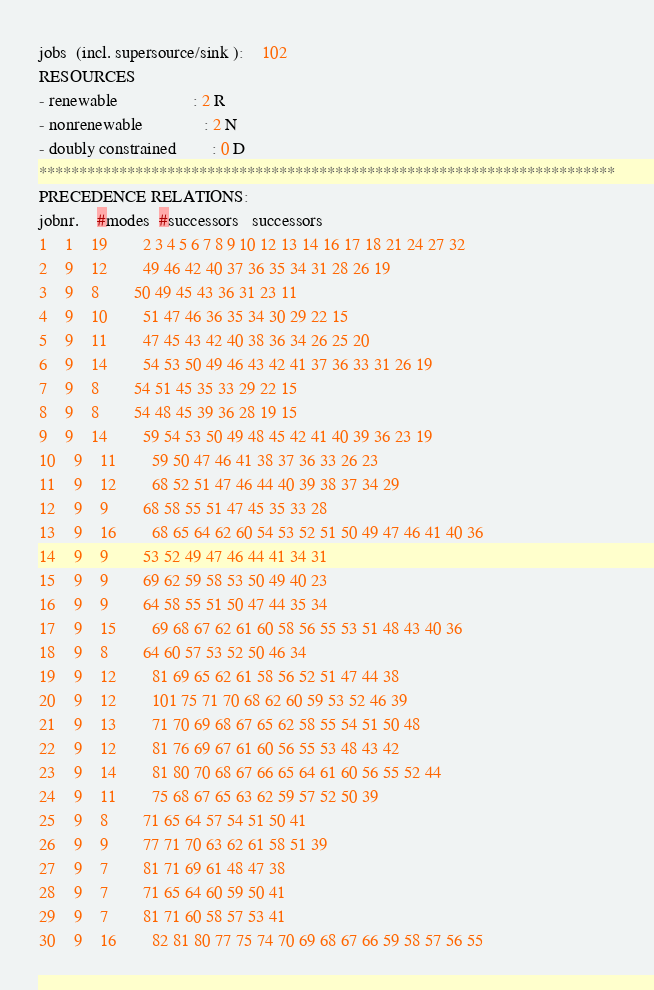Convert code to text. <code><loc_0><loc_0><loc_500><loc_500><_ObjectiveC_>jobs  (incl. supersource/sink ):	102
RESOURCES
- renewable                 : 2 R
- nonrenewable              : 2 N
- doubly constrained        : 0 D
************************************************************************
PRECEDENCE RELATIONS:
jobnr.    #modes  #successors   successors
1	1	19		2 3 4 5 6 7 8 9 10 12 13 14 16 17 18 21 24 27 32 
2	9	12		49 46 42 40 37 36 35 34 31 28 26 19 
3	9	8		50 49 45 43 36 31 23 11 
4	9	10		51 47 46 36 35 34 30 29 22 15 
5	9	11		47 45 43 42 40 38 36 34 26 25 20 
6	9	14		54 53 50 49 46 43 42 41 37 36 33 31 26 19 
7	9	8		54 51 45 35 33 29 22 15 
8	9	8		54 48 45 39 36 28 19 15 
9	9	14		59 54 53 50 49 48 45 42 41 40 39 36 23 19 
10	9	11		59 50 47 46 41 38 37 36 33 26 23 
11	9	12		68 52 51 47 46 44 40 39 38 37 34 29 
12	9	9		68 58 55 51 47 45 35 33 28 
13	9	16		68 65 64 62 60 54 53 52 51 50 49 47 46 41 40 36 
14	9	9		53 52 49 47 46 44 41 34 31 
15	9	9		69 62 59 58 53 50 49 40 23 
16	9	9		64 58 55 51 50 47 44 35 34 
17	9	15		69 68 67 62 61 60 58 56 55 53 51 48 43 40 36 
18	9	8		64 60 57 53 52 50 46 34 
19	9	12		81 69 65 62 61 58 56 52 51 47 44 38 
20	9	12		101 75 71 70 68 62 60 59 53 52 46 39 
21	9	13		71 70 69 68 67 65 62 58 55 54 51 50 48 
22	9	12		81 76 69 67 61 60 56 55 53 48 43 42 
23	9	14		81 80 70 68 67 66 65 64 61 60 56 55 52 44 
24	9	11		75 68 67 65 63 62 59 57 52 50 39 
25	9	8		71 65 64 57 54 51 50 41 
26	9	9		77 71 70 63 62 61 58 51 39 
27	9	7		81 71 69 61 48 47 38 
28	9	7		71 65 64 60 59 50 41 
29	9	7		81 71 60 58 57 53 41 
30	9	16		82 81 80 77 75 74 70 69 68 67 66 59 58 57 56 55 </code> 